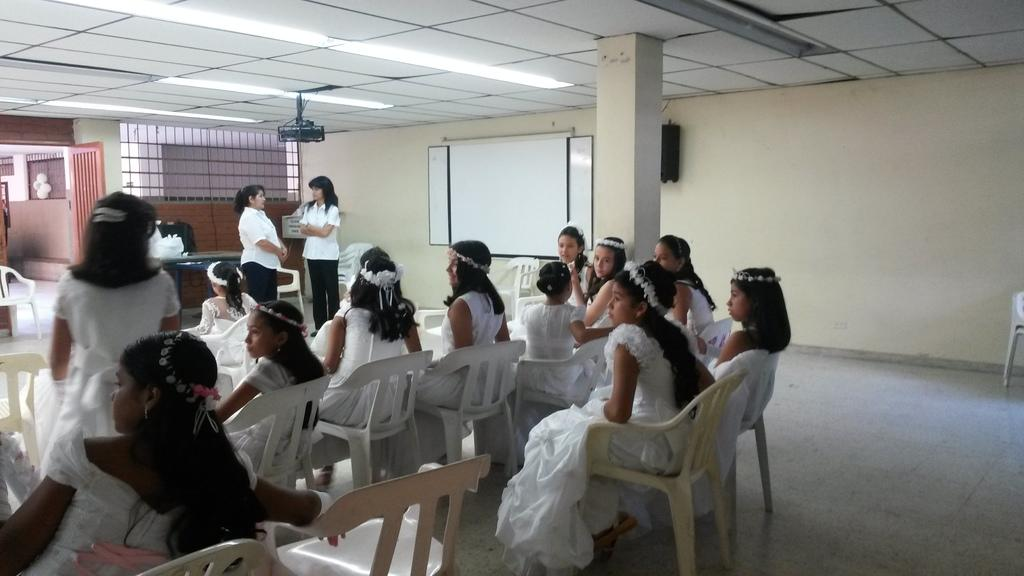What are the people in the image doing? People are sitting on chairs in the image. What is on the table in the image? There is a bag on the table in the image. What device is present for displaying information? There is a projector in the image. What surface is available for writing or displaying notes? There is a whiteboard on the wall in the image. Is there a way to enter or exit the room in the image? Yes, there is a door in the image. What direction is the thumb pointing in the image? There is no thumb present in the image. What type of wire is connected to the projector in the image? There is no wire connected to the projector in the image. 